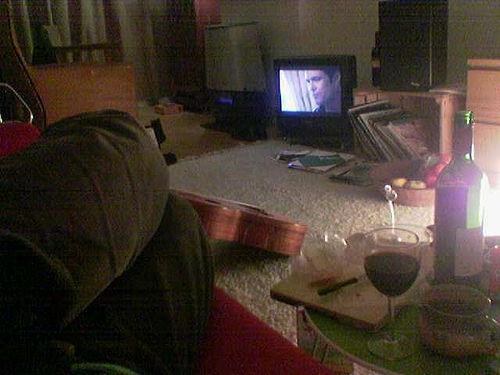How many boats are in front of the church?
Give a very brief answer. 0. 